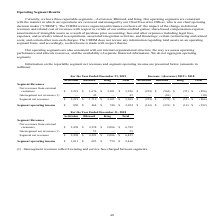According to Activision Blizzard's financial document, What is the Net revenues from external customers from Activision? According to the financial document, $2,458 (in millions). The relevant text states: "Net revenues from external customers $ 2,458 $ 2,238 $ 2,086 $ 6,782..." Also, What is the Net revenues from external customers from Blizzard? According to the financial document, $2,238 (in millions). The relevant text states: "Net revenues from external customers $ 2,458 $ 2,238 $ 2,086 $ 6,782..." Also, What is the total Segment net revenues? According to the financial document, $6,835 (in millions). The relevant text states: "Segment net revenues $ 2,458 $ 2,291 $ 2,086 $ 6,835..." Also, can you calculate: What is the difference in Net revenues from external customers between Activision and Blizzard? Based on the calculation: ($2,458-$2,238), the result is 220 (in millions). This is based on the information: "Net revenues from external customers $ 2,458 $ 2,238 $ 2,086 $ 6,782 Net revenues from external customers $ 2,458 $ 2,238 $ 2,086 $ 6,782..." The key data points involved are: 2,238, 2,458. Also, can you calculate: What percentage of the total Net revenues from external customers does King contribute? Based on the calculation: ($2,086/$6,782), the result is 30.76 (percentage). This is based on the information: "evenues from external customers $ 2,458 $ 2,238 $ 2,086 $ 6,782 from external customers $ 2,458 $ 2,238 $ 2,086 $ 6,782..." The key data points involved are: 2,086, 6,782. Also, can you calculate: What is the total segment operating income of Activision and King? Based on the calculation: $1,011+$750, the result is 1761 (in millions). This is based on the information: "Segment operating income $ 1,011 $ 685 $ 750 $ 2,446 Segment operating income $ 1,011 $ 685 $ 750 $ 2,446..." The key data points involved are: 1,011, 750. 